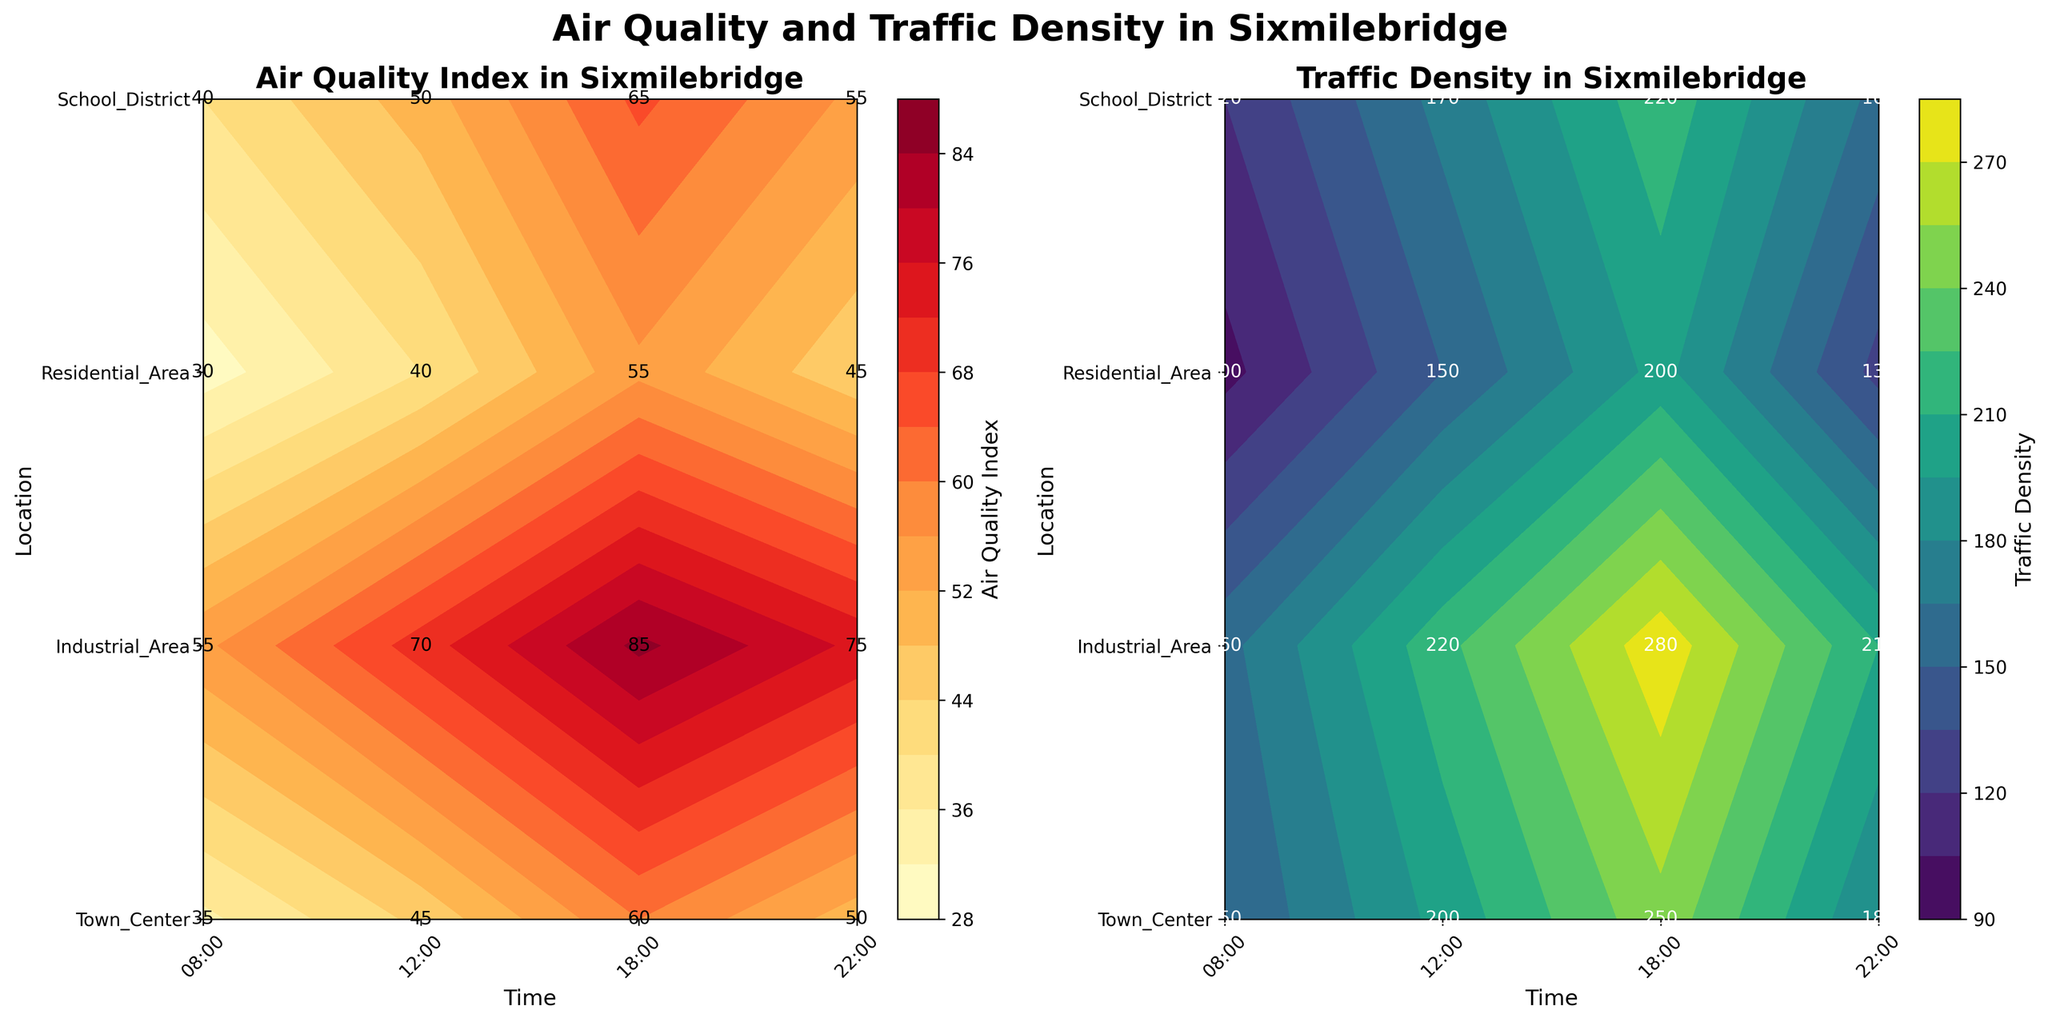What is the highest Air Quality Index recorded in the Town Center? The Town Center graph shows the contour labels indicating the Air Quality Index values at different times. By observing the labels, we find the highest value is 60 at 18:00.
Answer: 60 Which location had the highest Traffic Density at 18:00? By looking at the Traffic Density plot, we identify the highest value at 18:00 as 280, which occurs in the Industrial Area.
Answer: Industrial Area At what time was the Air Quality Index highest in the Industrial Area? Referring to the Air Quality Index contour plot, we look for the highest contour label in the Industrial Area row, which is 18:00 with a value of 85.
Answer: 18:00 How does the Traffic Density in the Residential Area at 12:00 compare to that in the School District at the same time? Comparing the labels at 12:00 in the Traffic Density plot for both locations, we find 150 for the Residential Area and 170 for the School District. Thus, the School District has higher density.
Answer: School District What is the average Air Quality Index at 08:00 across all locations? Summing the values from the Air Quality Index plot: Town Center (35), Industrial Area (55), Residential Area (30), School District (40). Average = (35 + 55 + 30 + 40) / 4 = 40.
Answer: 40 During which time period does the Town Center experience the lowest Traffic Density? Observing the Traffic Density labels in the Town Center row, the lowest value is 150 at 08:00.
Answer: 08:00 What is the difference in Air Quality Index between the Residential Area and Industrial Area at 22:00? From the Air Quality Index plot at 22:00, we have Residential Area (45) and Industrial Area (75). Difference = 75 - 45 = 30.
Answer: 30 Which location shows the greatest variability in Traffic Density throughout the day? By analyzing the range of Traffic Density values for each location, we see that the Industrial Area varies from 160 to 280 (range of 120), which is the greatest variability among the locations.
Answer: Industrial Area 